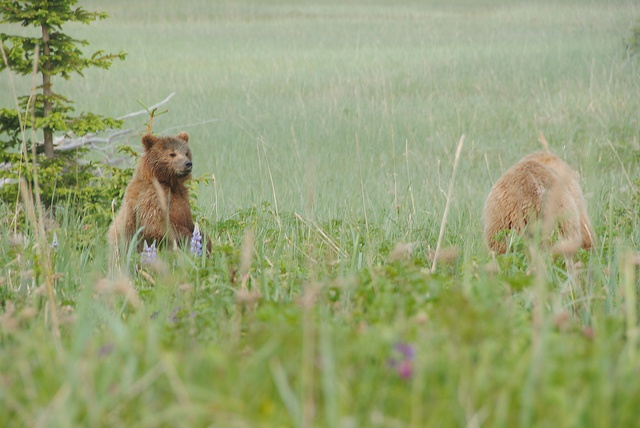Describe the objects in this image and their specific colors. I can see bear in olive, tan, and gray tones and bear in olive, tan, gray, darkgray, and maroon tones in this image. 